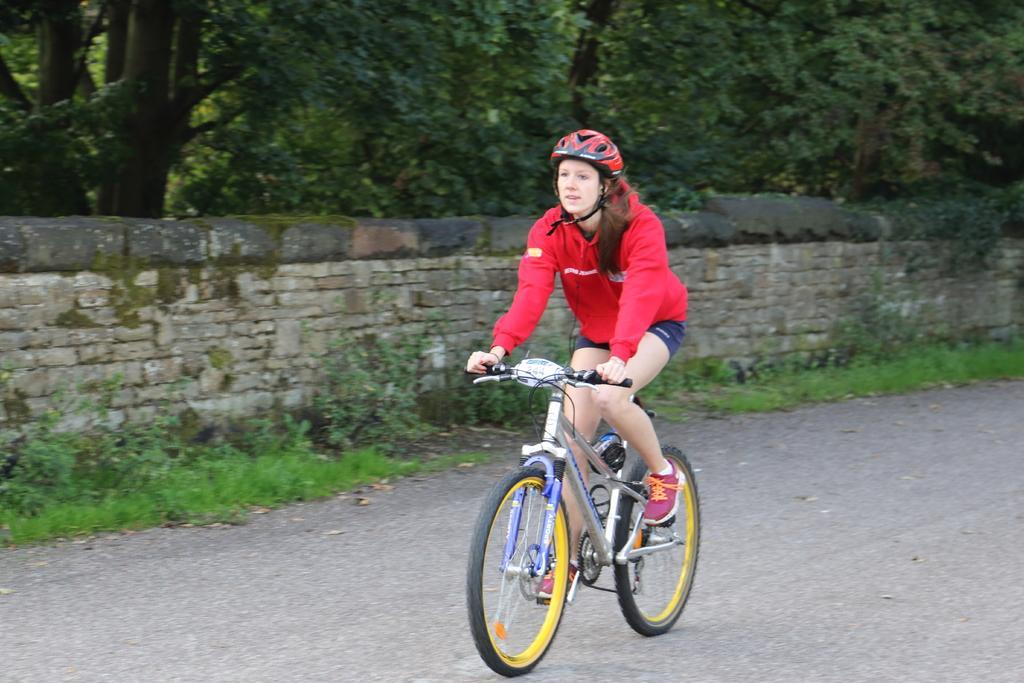Describe this image in one or two sentences. In this image we can see a person riding a bicycle on the road, there are some plants, trees and grass, also we can see the wall. 